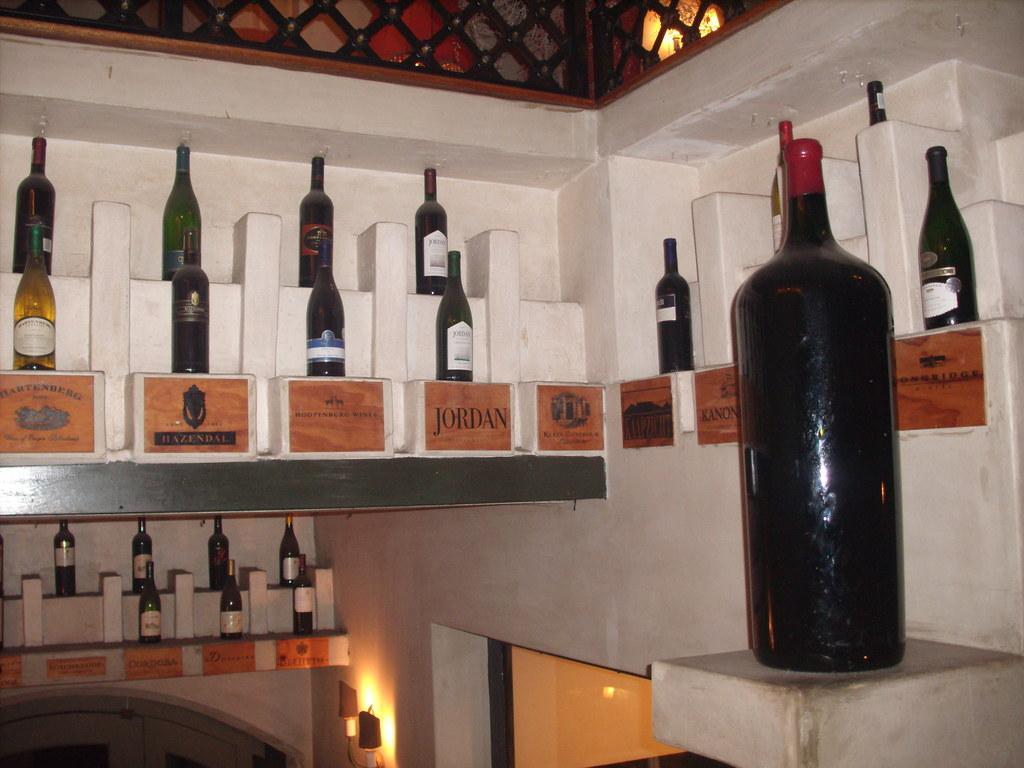Can you describe this image briefly? In this image we have a bottles back side they have so many bottles and bottom of the bottle we have a printed plate which is describing the bottle.. 